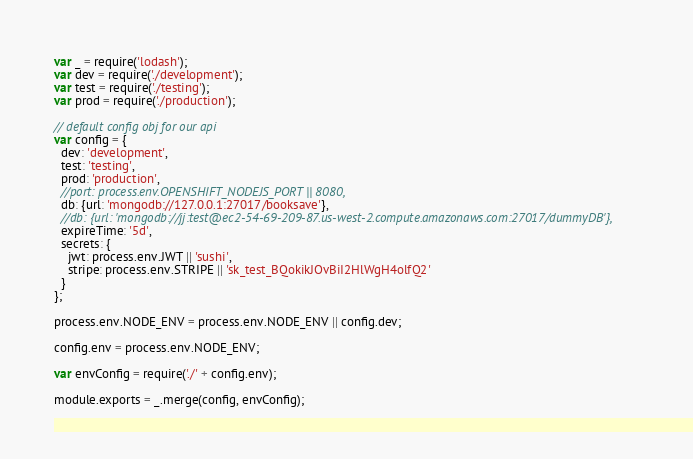<code> <loc_0><loc_0><loc_500><loc_500><_JavaScript_>var _ = require('lodash');
var dev = require('./development');
var test = require('./testing');
var prod = require('./production');

// default config obj for our api
var config = {
  dev: 'development',
  test: 'testing',
  prod: 'production',
  //port: process.env.OPENSHIFT_NODEJS_PORT || 8080,
  db: {url: 'mongodb://127.0.0.1:27017/booksave'},
  //db: {url: 'mongodb://jj:test@ec2-54-69-209-87.us-west-2.compute.amazonaws.com:27017/dummyDB'},
  expireTime: '5d',
  secrets: {
    jwt: process.env.JWT || 'sushi',
    stripe: process.env.STRIPE || 'sk_test_BQokikJOvBiI2HlWgH4olfQ2'
  }
};

process.env.NODE_ENV = process.env.NODE_ENV || config.dev;

config.env = process.env.NODE_ENV;

var envConfig = require('./' + config.env);

module.exports = _.merge(config, envConfig);</code> 